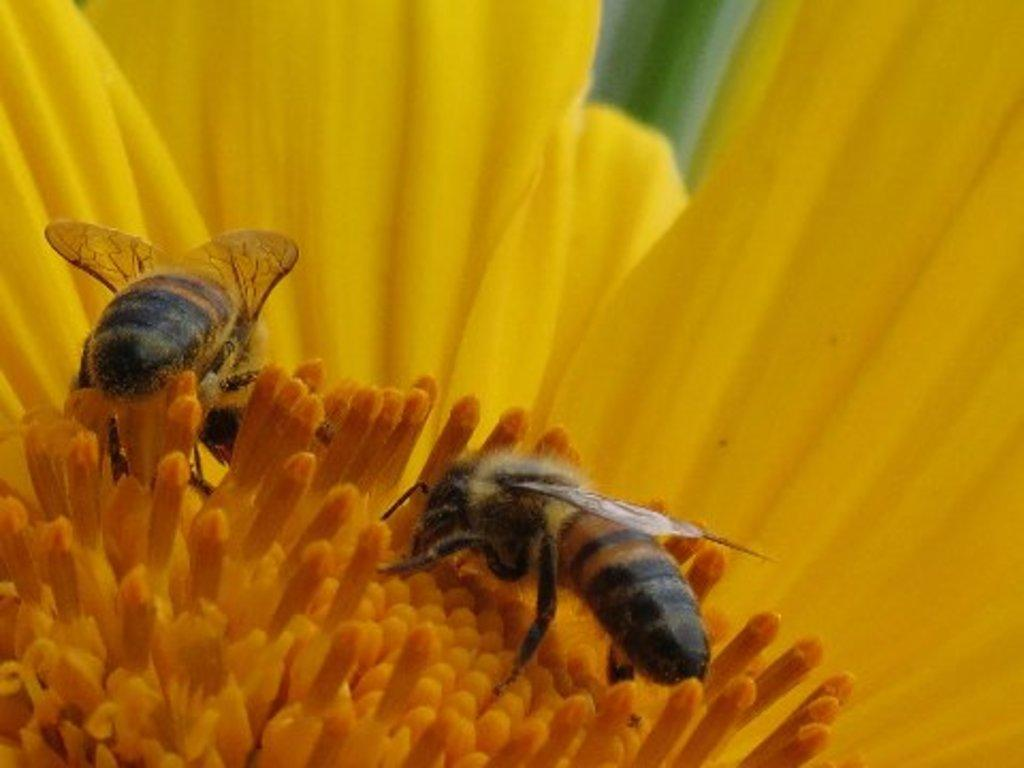What type of insects are present in the image? There are bees in the image. What are the bees doing in the image? The bees are on a yellow flower. What type of grain is visible in the image? There is no grain present in the image; it features bees on a yellow flower. How do the chairs in the image affect the behavior of the bees? There are no chairs present in the image, so their impact on the bees' behavior cannot be determined. 